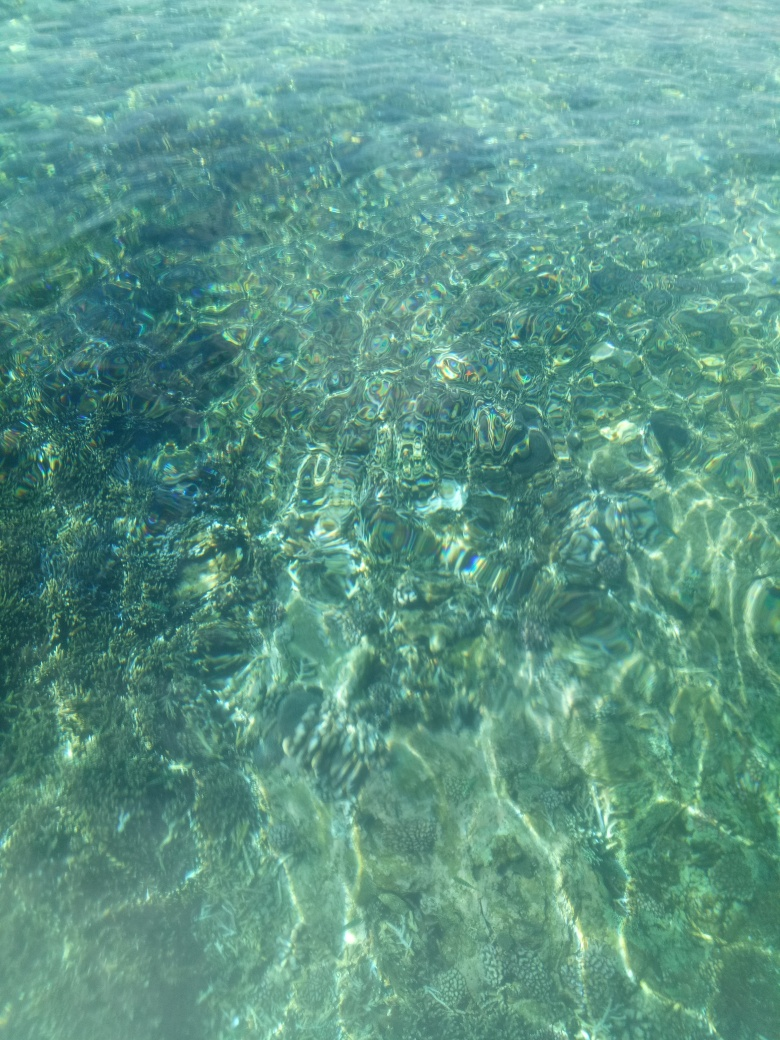What might be the depth of the water in this image? Given the visibility and the scale of the patterns seen through the water, the depth could be relatively shallow, perhaps no more than a few meters. It's clear enough to see details on the bottom, which usually indicates shallower waters. 